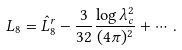<formula> <loc_0><loc_0><loc_500><loc_500>L _ { 8 } = \hat { L } _ { 8 } ^ { r } - \frac { 3 } { 3 2 } \frac { \log \lambda _ { c } ^ { 2 } } { ( 4 \pi ) ^ { 2 } } + \cdots \, .</formula> 